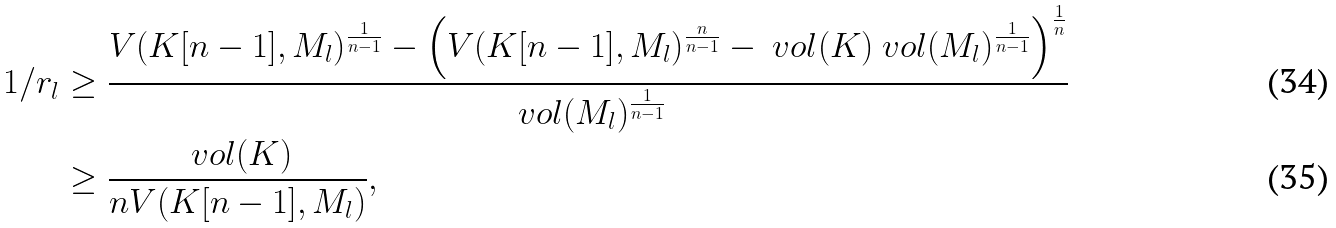Convert formula to latex. <formula><loc_0><loc_0><loc_500><loc_500>1 / r _ { l } & \geq \frac { V ( K [ n - 1 ] , M _ { l } ) ^ { \frac { 1 } { n - 1 } } - \left ( V ( K [ n - 1 ] , M _ { l } ) ^ { \frac { n } { n - 1 } } - \ v o l ( K ) \ v o l ( M _ { l } ) ^ { \frac { 1 } { n - 1 } } \right ) ^ { \frac { 1 } { n } } } { \ v o l ( M _ { l } ) ^ { \frac { 1 } { n - 1 } } } \\ & \geq \frac { \ v o l ( K ) } { n V ( K [ n - 1 ] , M _ { l } ) } ,</formula> 